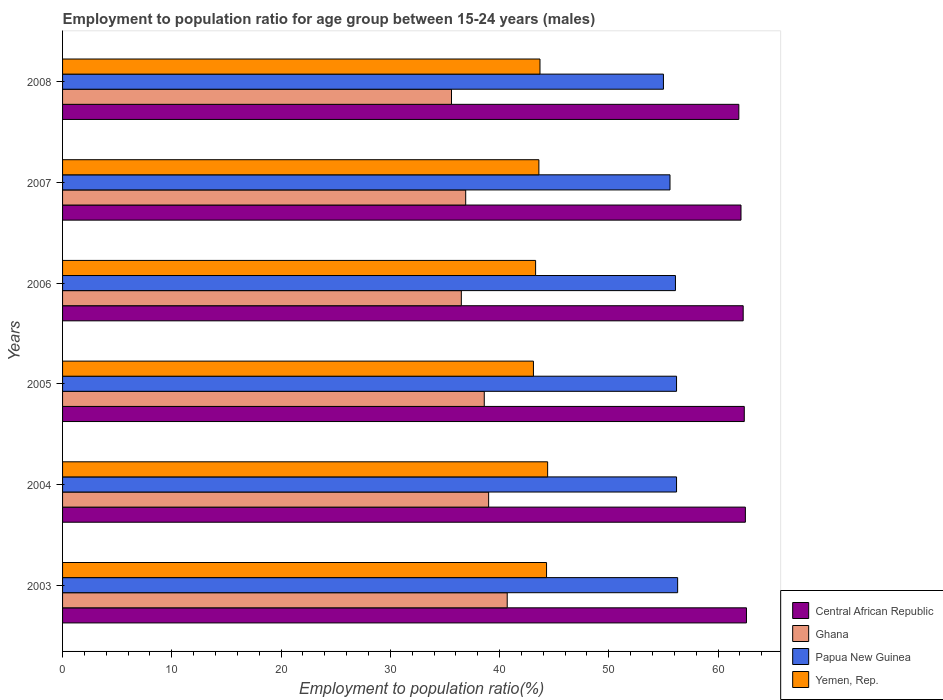How many different coloured bars are there?
Offer a terse response. 4. How many groups of bars are there?
Ensure brevity in your answer.  6. How many bars are there on the 4th tick from the bottom?
Provide a short and direct response. 4. What is the employment to population ratio in Central African Republic in 2006?
Give a very brief answer. 62.3. Across all years, what is the maximum employment to population ratio in Ghana?
Give a very brief answer. 40.7. Across all years, what is the minimum employment to population ratio in Ghana?
Offer a very short reply. 35.6. In which year was the employment to population ratio in Ghana minimum?
Your answer should be compact. 2008. What is the total employment to population ratio in Central African Republic in the graph?
Your answer should be compact. 373.8. What is the difference between the employment to population ratio in Central African Republic in 2004 and that in 2006?
Ensure brevity in your answer.  0.2. What is the difference between the employment to population ratio in Papua New Guinea in 2004 and the employment to population ratio in Yemen, Rep. in 2006?
Provide a short and direct response. 12.9. What is the average employment to population ratio in Papua New Guinea per year?
Offer a terse response. 55.9. In the year 2005, what is the difference between the employment to population ratio in Central African Republic and employment to population ratio in Ghana?
Your response must be concise. 23.8. What is the ratio of the employment to population ratio in Yemen, Rep. in 2005 to that in 2006?
Make the answer very short. 1. Is the employment to population ratio in Papua New Guinea in 2003 less than that in 2005?
Offer a terse response. No. Is the difference between the employment to population ratio in Central African Republic in 2004 and 2005 greater than the difference between the employment to population ratio in Ghana in 2004 and 2005?
Offer a terse response. No. What is the difference between the highest and the second highest employment to population ratio in Papua New Guinea?
Your answer should be very brief. 0.1. What is the difference between the highest and the lowest employment to population ratio in Papua New Guinea?
Ensure brevity in your answer.  1.3. Is it the case that in every year, the sum of the employment to population ratio in Ghana and employment to population ratio in Yemen, Rep. is greater than the sum of employment to population ratio in Papua New Guinea and employment to population ratio in Central African Republic?
Offer a terse response. Yes. What does the 2nd bar from the top in 2008 represents?
Offer a very short reply. Papua New Guinea. What does the 1st bar from the bottom in 2005 represents?
Keep it short and to the point. Central African Republic. Is it the case that in every year, the sum of the employment to population ratio in Yemen, Rep. and employment to population ratio in Papua New Guinea is greater than the employment to population ratio in Ghana?
Keep it short and to the point. Yes. How many bars are there?
Give a very brief answer. 24. Are all the bars in the graph horizontal?
Your answer should be very brief. Yes. How many years are there in the graph?
Keep it short and to the point. 6. What is the difference between two consecutive major ticks on the X-axis?
Offer a very short reply. 10. Are the values on the major ticks of X-axis written in scientific E-notation?
Your answer should be compact. No. Does the graph contain any zero values?
Ensure brevity in your answer.  No. How are the legend labels stacked?
Offer a terse response. Vertical. What is the title of the graph?
Ensure brevity in your answer.  Employment to population ratio for age group between 15-24 years (males). What is the label or title of the X-axis?
Your answer should be very brief. Employment to population ratio(%). What is the label or title of the Y-axis?
Provide a succinct answer. Years. What is the Employment to population ratio(%) in Central African Republic in 2003?
Provide a succinct answer. 62.6. What is the Employment to population ratio(%) of Ghana in 2003?
Offer a terse response. 40.7. What is the Employment to population ratio(%) in Papua New Guinea in 2003?
Provide a short and direct response. 56.3. What is the Employment to population ratio(%) of Yemen, Rep. in 2003?
Your answer should be compact. 44.3. What is the Employment to population ratio(%) in Central African Republic in 2004?
Ensure brevity in your answer.  62.5. What is the Employment to population ratio(%) of Papua New Guinea in 2004?
Your response must be concise. 56.2. What is the Employment to population ratio(%) in Yemen, Rep. in 2004?
Your answer should be very brief. 44.4. What is the Employment to population ratio(%) in Central African Republic in 2005?
Offer a terse response. 62.4. What is the Employment to population ratio(%) of Ghana in 2005?
Give a very brief answer. 38.6. What is the Employment to population ratio(%) in Papua New Guinea in 2005?
Provide a succinct answer. 56.2. What is the Employment to population ratio(%) in Yemen, Rep. in 2005?
Give a very brief answer. 43.1. What is the Employment to population ratio(%) of Central African Republic in 2006?
Offer a terse response. 62.3. What is the Employment to population ratio(%) of Ghana in 2006?
Your response must be concise. 36.5. What is the Employment to population ratio(%) of Papua New Guinea in 2006?
Provide a short and direct response. 56.1. What is the Employment to population ratio(%) of Yemen, Rep. in 2006?
Offer a terse response. 43.3. What is the Employment to population ratio(%) of Central African Republic in 2007?
Your answer should be very brief. 62.1. What is the Employment to population ratio(%) of Ghana in 2007?
Your answer should be very brief. 36.9. What is the Employment to population ratio(%) in Papua New Guinea in 2007?
Give a very brief answer. 55.6. What is the Employment to population ratio(%) in Yemen, Rep. in 2007?
Offer a very short reply. 43.6. What is the Employment to population ratio(%) of Central African Republic in 2008?
Keep it short and to the point. 61.9. What is the Employment to population ratio(%) of Ghana in 2008?
Your answer should be very brief. 35.6. What is the Employment to population ratio(%) of Yemen, Rep. in 2008?
Your answer should be compact. 43.7. Across all years, what is the maximum Employment to population ratio(%) in Central African Republic?
Offer a very short reply. 62.6. Across all years, what is the maximum Employment to population ratio(%) of Ghana?
Offer a very short reply. 40.7. Across all years, what is the maximum Employment to population ratio(%) in Papua New Guinea?
Your response must be concise. 56.3. Across all years, what is the maximum Employment to population ratio(%) of Yemen, Rep.?
Give a very brief answer. 44.4. Across all years, what is the minimum Employment to population ratio(%) in Central African Republic?
Make the answer very short. 61.9. Across all years, what is the minimum Employment to population ratio(%) in Ghana?
Offer a very short reply. 35.6. Across all years, what is the minimum Employment to population ratio(%) of Yemen, Rep.?
Offer a very short reply. 43.1. What is the total Employment to population ratio(%) in Central African Republic in the graph?
Provide a short and direct response. 373.8. What is the total Employment to population ratio(%) of Ghana in the graph?
Provide a succinct answer. 227.3. What is the total Employment to population ratio(%) of Papua New Guinea in the graph?
Keep it short and to the point. 335.4. What is the total Employment to population ratio(%) in Yemen, Rep. in the graph?
Your answer should be very brief. 262.4. What is the difference between the Employment to population ratio(%) of Central African Republic in 2003 and that in 2004?
Ensure brevity in your answer.  0.1. What is the difference between the Employment to population ratio(%) of Papua New Guinea in 2003 and that in 2004?
Offer a terse response. 0.1. What is the difference between the Employment to population ratio(%) in Yemen, Rep. in 2003 and that in 2004?
Make the answer very short. -0.1. What is the difference between the Employment to population ratio(%) of Central African Republic in 2003 and that in 2005?
Offer a terse response. 0.2. What is the difference between the Employment to population ratio(%) in Yemen, Rep. in 2003 and that in 2005?
Make the answer very short. 1.2. What is the difference between the Employment to population ratio(%) in Ghana in 2003 and that in 2006?
Make the answer very short. 4.2. What is the difference between the Employment to population ratio(%) in Papua New Guinea in 2003 and that in 2006?
Offer a terse response. 0.2. What is the difference between the Employment to population ratio(%) of Yemen, Rep. in 2003 and that in 2006?
Your answer should be compact. 1. What is the difference between the Employment to population ratio(%) of Central African Republic in 2003 and that in 2007?
Your response must be concise. 0.5. What is the difference between the Employment to population ratio(%) in Ghana in 2003 and that in 2007?
Offer a terse response. 3.8. What is the difference between the Employment to population ratio(%) in Central African Republic in 2003 and that in 2008?
Offer a very short reply. 0.7. What is the difference between the Employment to population ratio(%) in Ghana in 2003 and that in 2008?
Keep it short and to the point. 5.1. What is the difference between the Employment to population ratio(%) in Papua New Guinea in 2003 and that in 2008?
Offer a very short reply. 1.3. What is the difference between the Employment to population ratio(%) of Ghana in 2004 and that in 2005?
Your answer should be very brief. 0.4. What is the difference between the Employment to population ratio(%) in Yemen, Rep. in 2004 and that in 2005?
Provide a short and direct response. 1.3. What is the difference between the Employment to population ratio(%) of Ghana in 2004 and that in 2006?
Offer a terse response. 2.5. What is the difference between the Employment to population ratio(%) of Papua New Guinea in 2004 and that in 2006?
Your answer should be very brief. 0.1. What is the difference between the Employment to population ratio(%) in Central African Republic in 2004 and that in 2007?
Offer a very short reply. 0.4. What is the difference between the Employment to population ratio(%) in Yemen, Rep. in 2004 and that in 2008?
Ensure brevity in your answer.  0.7. What is the difference between the Employment to population ratio(%) of Central African Republic in 2005 and that in 2006?
Your answer should be compact. 0.1. What is the difference between the Employment to population ratio(%) in Ghana in 2005 and that in 2007?
Provide a succinct answer. 1.7. What is the difference between the Employment to population ratio(%) of Ghana in 2005 and that in 2008?
Offer a very short reply. 3. What is the difference between the Employment to population ratio(%) of Papua New Guinea in 2005 and that in 2008?
Make the answer very short. 1.2. What is the difference between the Employment to population ratio(%) in Yemen, Rep. in 2005 and that in 2008?
Make the answer very short. -0.6. What is the difference between the Employment to population ratio(%) in Papua New Guinea in 2006 and that in 2008?
Keep it short and to the point. 1.1. What is the difference between the Employment to population ratio(%) in Central African Republic in 2003 and the Employment to population ratio(%) in Ghana in 2004?
Provide a short and direct response. 23.6. What is the difference between the Employment to population ratio(%) in Central African Republic in 2003 and the Employment to population ratio(%) in Papua New Guinea in 2004?
Provide a succinct answer. 6.4. What is the difference between the Employment to population ratio(%) of Ghana in 2003 and the Employment to population ratio(%) of Papua New Guinea in 2004?
Keep it short and to the point. -15.5. What is the difference between the Employment to population ratio(%) in Papua New Guinea in 2003 and the Employment to population ratio(%) in Yemen, Rep. in 2004?
Keep it short and to the point. 11.9. What is the difference between the Employment to population ratio(%) in Central African Republic in 2003 and the Employment to population ratio(%) in Ghana in 2005?
Your answer should be compact. 24. What is the difference between the Employment to population ratio(%) of Central African Republic in 2003 and the Employment to population ratio(%) of Papua New Guinea in 2005?
Provide a short and direct response. 6.4. What is the difference between the Employment to population ratio(%) of Central African Republic in 2003 and the Employment to population ratio(%) of Yemen, Rep. in 2005?
Your response must be concise. 19.5. What is the difference between the Employment to population ratio(%) in Ghana in 2003 and the Employment to population ratio(%) in Papua New Guinea in 2005?
Your answer should be compact. -15.5. What is the difference between the Employment to population ratio(%) of Papua New Guinea in 2003 and the Employment to population ratio(%) of Yemen, Rep. in 2005?
Keep it short and to the point. 13.2. What is the difference between the Employment to population ratio(%) of Central African Republic in 2003 and the Employment to population ratio(%) of Ghana in 2006?
Ensure brevity in your answer.  26.1. What is the difference between the Employment to population ratio(%) in Central African Republic in 2003 and the Employment to population ratio(%) in Yemen, Rep. in 2006?
Keep it short and to the point. 19.3. What is the difference between the Employment to population ratio(%) of Ghana in 2003 and the Employment to population ratio(%) of Papua New Guinea in 2006?
Offer a terse response. -15.4. What is the difference between the Employment to population ratio(%) in Central African Republic in 2003 and the Employment to population ratio(%) in Ghana in 2007?
Keep it short and to the point. 25.7. What is the difference between the Employment to population ratio(%) of Central African Republic in 2003 and the Employment to population ratio(%) of Papua New Guinea in 2007?
Your answer should be compact. 7. What is the difference between the Employment to population ratio(%) in Ghana in 2003 and the Employment to population ratio(%) in Papua New Guinea in 2007?
Your answer should be compact. -14.9. What is the difference between the Employment to population ratio(%) in Ghana in 2003 and the Employment to population ratio(%) in Yemen, Rep. in 2007?
Provide a short and direct response. -2.9. What is the difference between the Employment to population ratio(%) of Papua New Guinea in 2003 and the Employment to population ratio(%) of Yemen, Rep. in 2007?
Ensure brevity in your answer.  12.7. What is the difference between the Employment to population ratio(%) in Central African Republic in 2003 and the Employment to population ratio(%) in Ghana in 2008?
Offer a very short reply. 27. What is the difference between the Employment to population ratio(%) of Central African Republic in 2003 and the Employment to population ratio(%) of Papua New Guinea in 2008?
Make the answer very short. 7.6. What is the difference between the Employment to population ratio(%) of Ghana in 2003 and the Employment to population ratio(%) of Papua New Guinea in 2008?
Offer a very short reply. -14.3. What is the difference between the Employment to population ratio(%) of Papua New Guinea in 2003 and the Employment to population ratio(%) of Yemen, Rep. in 2008?
Provide a succinct answer. 12.6. What is the difference between the Employment to population ratio(%) in Central African Republic in 2004 and the Employment to population ratio(%) in Ghana in 2005?
Provide a succinct answer. 23.9. What is the difference between the Employment to population ratio(%) in Central African Republic in 2004 and the Employment to population ratio(%) in Yemen, Rep. in 2005?
Give a very brief answer. 19.4. What is the difference between the Employment to population ratio(%) of Ghana in 2004 and the Employment to population ratio(%) of Papua New Guinea in 2005?
Ensure brevity in your answer.  -17.2. What is the difference between the Employment to population ratio(%) of Papua New Guinea in 2004 and the Employment to population ratio(%) of Yemen, Rep. in 2005?
Offer a terse response. 13.1. What is the difference between the Employment to population ratio(%) in Central African Republic in 2004 and the Employment to population ratio(%) in Ghana in 2006?
Offer a terse response. 26. What is the difference between the Employment to population ratio(%) in Central African Republic in 2004 and the Employment to population ratio(%) in Papua New Guinea in 2006?
Ensure brevity in your answer.  6.4. What is the difference between the Employment to population ratio(%) of Ghana in 2004 and the Employment to population ratio(%) of Papua New Guinea in 2006?
Make the answer very short. -17.1. What is the difference between the Employment to population ratio(%) in Ghana in 2004 and the Employment to population ratio(%) in Yemen, Rep. in 2006?
Your answer should be very brief. -4.3. What is the difference between the Employment to population ratio(%) of Central African Republic in 2004 and the Employment to population ratio(%) of Ghana in 2007?
Offer a terse response. 25.6. What is the difference between the Employment to population ratio(%) in Central African Republic in 2004 and the Employment to population ratio(%) in Papua New Guinea in 2007?
Give a very brief answer. 6.9. What is the difference between the Employment to population ratio(%) in Ghana in 2004 and the Employment to population ratio(%) in Papua New Guinea in 2007?
Offer a very short reply. -16.6. What is the difference between the Employment to population ratio(%) of Ghana in 2004 and the Employment to population ratio(%) of Yemen, Rep. in 2007?
Give a very brief answer. -4.6. What is the difference between the Employment to population ratio(%) of Central African Republic in 2004 and the Employment to population ratio(%) of Ghana in 2008?
Offer a very short reply. 26.9. What is the difference between the Employment to population ratio(%) in Central African Republic in 2004 and the Employment to population ratio(%) in Papua New Guinea in 2008?
Give a very brief answer. 7.5. What is the difference between the Employment to population ratio(%) in Ghana in 2004 and the Employment to population ratio(%) in Papua New Guinea in 2008?
Ensure brevity in your answer.  -16. What is the difference between the Employment to population ratio(%) in Ghana in 2004 and the Employment to population ratio(%) in Yemen, Rep. in 2008?
Offer a very short reply. -4.7. What is the difference between the Employment to population ratio(%) of Papua New Guinea in 2004 and the Employment to population ratio(%) of Yemen, Rep. in 2008?
Offer a very short reply. 12.5. What is the difference between the Employment to population ratio(%) of Central African Republic in 2005 and the Employment to population ratio(%) of Ghana in 2006?
Make the answer very short. 25.9. What is the difference between the Employment to population ratio(%) in Central African Republic in 2005 and the Employment to population ratio(%) in Papua New Guinea in 2006?
Keep it short and to the point. 6.3. What is the difference between the Employment to population ratio(%) in Ghana in 2005 and the Employment to population ratio(%) in Papua New Guinea in 2006?
Your response must be concise. -17.5. What is the difference between the Employment to population ratio(%) in Papua New Guinea in 2005 and the Employment to population ratio(%) in Yemen, Rep. in 2006?
Offer a very short reply. 12.9. What is the difference between the Employment to population ratio(%) of Central African Republic in 2005 and the Employment to population ratio(%) of Papua New Guinea in 2007?
Your answer should be very brief. 6.8. What is the difference between the Employment to population ratio(%) in Ghana in 2005 and the Employment to population ratio(%) in Yemen, Rep. in 2007?
Your answer should be compact. -5. What is the difference between the Employment to population ratio(%) of Papua New Guinea in 2005 and the Employment to population ratio(%) of Yemen, Rep. in 2007?
Offer a terse response. 12.6. What is the difference between the Employment to population ratio(%) of Central African Republic in 2005 and the Employment to population ratio(%) of Ghana in 2008?
Offer a terse response. 26.8. What is the difference between the Employment to population ratio(%) of Central African Republic in 2005 and the Employment to population ratio(%) of Yemen, Rep. in 2008?
Make the answer very short. 18.7. What is the difference between the Employment to population ratio(%) in Ghana in 2005 and the Employment to population ratio(%) in Papua New Guinea in 2008?
Your answer should be compact. -16.4. What is the difference between the Employment to population ratio(%) in Ghana in 2005 and the Employment to population ratio(%) in Yemen, Rep. in 2008?
Your response must be concise. -5.1. What is the difference between the Employment to population ratio(%) in Papua New Guinea in 2005 and the Employment to population ratio(%) in Yemen, Rep. in 2008?
Give a very brief answer. 12.5. What is the difference between the Employment to population ratio(%) in Central African Republic in 2006 and the Employment to population ratio(%) in Ghana in 2007?
Make the answer very short. 25.4. What is the difference between the Employment to population ratio(%) in Central African Republic in 2006 and the Employment to population ratio(%) in Yemen, Rep. in 2007?
Your response must be concise. 18.7. What is the difference between the Employment to population ratio(%) of Ghana in 2006 and the Employment to population ratio(%) of Papua New Guinea in 2007?
Give a very brief answer. -19.1. What is the difference between the Employment to population ratio(%) in Papua New Guinea in 2006 and the Employment to population ratio(%) in Yemen, Rep. in 2007?
Give a very brief answer. 12.5. What is the difference between the Employment to population ratio(%) of Central African Republic in 2006 and the Employment to population ratio(%) of Ghana in 2008?
Ensure brevity in your answer.  26.7. What is the difference between the Employment to population ratio(%) in Central African Republic in 2006 and the Employment to population ratio(%) in Papua New Guinea in 2008?
Give a very brief answer. 7.3. What is the difference between the Employment to population ratio(%) in Central African Republic in 2006 and the Employment to population ratio(%) in Yemen, Rep. in 2008?
Your answer should be compact. 18.6. What is the difference between the Employment to population ratio(%) in Ghana in 2006 and the Employment to population ratio(%) in Papua New Guinea in 2008?
Offer a terse response. -18.5. What is the difference between the Employment to population ratio(%) in Ghana in 2006 and the Employment to population ratio(%) in Yemen, Rep. in 2008?
Provide a succinct answer. -7.2. What is the difference between the Employment to population ratio(%) in Papua New Guinea in 2006 and the Employment to population ratio(%) in Yemen, Rep. in 2008?
Ensure brevity in your answer.  12.4. What is the difference between the Employment to population ratio(%) in Central African Republic in 2007 and the Employment to population ratio(%) in Ghana in 2008?
Your response must be concise. 26.5. What is the difference between the Employment to population ratio(%) of Ghana in 2007 and the Employment to population ratio(%) of Papua New Guinea in 2008?
Give a very brief answer. -18.1. What is the average Employment to population ratio(%) in Central African Republic per year?
Make the answer very short. 62.3. What is the average Employment to population ratio(%) in Ghana per year?
Keep it short and to the point. 37.88. What is the average Employment to population ratio(%) in Papua New Guinea per year?
Keep it short and to the point. 55.9. What is the average Employment to population ratio(%) of Yemen, Rep. per year?
Make the answer very short. 43.73. In the year 2003, what is the difference between the Employment to population ratio(%) in Central African Republic and Employment to population ratio(%) in Ghana?
Offer a very short reply. 21.9. In the year 2003, what is the difference between the Employment to population ratio(%) of Central African Republic and Employment to population ratio(%) of Yemen, Rep.?
Your answer should be very brief. 18.3. In the year 2003, what is the difference between the Employment to population ratio(%) of Ghana and Employment to population ratio(%) of Papua New Guinea?
Give a very brief answer. -15.6. In the year 2003, what is the difference between the Employment to population ratio(%) of Ghana and Employment to population ratio(%) of Yemen, Rep.?
Provide a succinct answer. -3.6. In the year 2003, what is the difference between the Employment to population ratio(%) of Papua New Guinea and Employment to population ratio(%) of Yemen, Rep.?
Ensure brevity in your answer.  12. In the year 2004, what is the difference between the Employment to population ratio(%) of Central African Republic and Employment to population ratio(%) of Ghana?
Your response must be concise. 23.5. In the year 2004, what is the difference between the Employment to population ratio(%) in Ghana and Employment to population ratio(%) in Papua New Guinea?
Make the answer very short. -17.2. In the year 2005, what is the difference between the Employment to population ratio(%) of Central African Republic and Employment to population ratio(%) of Ghana?
Give a very brief answer. 23.8. In the year 2005, what is the difference between the Employment to population ratio(%) in Central African Republic and Employment to population ratio(%) in Papua New Guinea?
Ensure brevity in your answer.  6.2. In the year 2005, what is the difference between the Employment to population ratio(%) in Central African Republic and Employment to population ratio(%) in Yemen, Rep.?
Your response must be concise. 19.3. In the year 2005, what is the difference between the Employment to population ratio(%) of Ghana and Employment to population ratio(%) of Papua New Guinea?
Ensure brevity in your answer.  -17.6. In the year 2005, what is the difference between the Employment to population ratio(%) of Papua New Guinea and Employment to population ratio(%) of Yemen, Rep.?
Your answer should be very brief. 13.1. In the year 2006, what is the difference between the Employment to population ratio(%) of Central African Republic and Employment to population ratio(%) of Ghana?
Your response must be concise. 25.8. In the year 2006, what is the difference between the Employment to population ratio(%) in Central African Republic and Employment to population ratio(%) in Papua New Guinea?
Your answer should be compact. 6.2. In the year 2006, what is the difference between the Employment to population ratio(%) of Central African Republic and Employment to population ratio(%) of Yemen, Rep.?
Your answer should be compact. 19. In the year 2006, what is the difference between the Employment to population ratio(%) of Ghana and Employment to population ratio(%) of Papua New Guinea?
Provide a succinct answer. -19.6. In the year 2006, what is the difference between the Employment to population ratio(%) of Ghana and Employment to population ratio(%) of Yemen, Rep.?
Offer a terse response. -6.8. In the year 2007, what is the difference between the Employment to population ratio(%) of Central African Republic and Employment to population ratio(%) of Ghana?
Provide a short and direct response. 25.2. In the year 2007, what is the difference between the Employment to population ratio(%) in Central African Republic and Employment to population ratio(%) in Yemen, Rep.?
Keep it short and to the point. 18.5. In the year 2007, what is the difference between the Employment to population ratio(%) of Ghana and Employment to population ratio(%) of Papua New Guinea?
Ensure brevity in your answer.  -18.7. In the year 2008, what is the difference between the Employment to population ratio(%) in Central African Republic and Employment to population ratio(%) in Ghana?
Ensure brevity in your answer.  26.3. In the year 2008, what is the difference between the Employment to population ratio(%) of Central African Republic and Employment to population ratio(%) of Yemen, Rep.?
Give a very brief answer. 18.2. In the year 2008, what is the difference between the Employment to population ratio(%) of Ghana and Employment to population ratio(%) of Papua New Guinea?
Make the answer very short. -19.4. In the year 2008, what is the difference between the Employment to population ratio(%) in Ghana and Employment to population ratio(%) in Yemen, Rep.?
Make the answer very short. -8.1. What is the ratio of the Employment to population ratio(%) in Central African Republic in 2003 to that in 2004?
Your answer should be compact. 1. What is the ratio of the Employment to population ratio(%) in Ghana in 2003 to that in 2004?
Make the answer very short. 1.04. What is the ratio of the Employment to population ratio(%) of Central African Republic in 2003 to that in 2005?
Give a very brief answer. 1. What is the ratio of the Employment to population ratio(%) of Ghana in 2003 to that in 2005?
Keep it short and to the point. 1.05. What is the ratio of the Employment to population ratio(%) in Papua New Guinea in 2003 to that in 2005?
Offer a very short reply. 1. What is the ratio of the Employment to population ratio(%) of Yemen, Rep. in 2003 to that in 2005?
Keep it short and to the point. 1.03. What is the ratio of the Employment to population ratio(%) of Ghana in 2003 to that in 2006?
Provide a short and direct response. 1.12. What is the ratio of the Employment to population ratio(%) of Yemen, Rep. in 2003 to that in 2006?
Make the answer very short. 1.02. What is the ratio of the Employment to population ratio(%) of Ghana in 2003 to that in 2007?
Make the answer very short. 1.1. What is the ratio of the Employment to population ratio(%) in Papua New Guinea in 2003 to that in 2007?
Give a very brief answer. 1.01. What is the ratio of the Employment to population ratio(%) in Yemen, Rep. in 2003 to that in 2007?
Your response must be concise. 1.02. What is the ratio of the Employment to population ratio(%) in Central African Republic in 2003 to that in 2008?
Make the answer very short. 1.01. What is the ratio of the Employment to population ratio(%) in Ghana in 2003 to that in 2008?
Make the answer very short. 1.14. What is the ratio of the Employment to population ratio(%) in Papua New Guinea in 2003 to that in 2008?
Give a very brief answer. 1.02. What is the ratio of the Employment to population ratio(%) in Yemen, Rep. in 2003 to that in 2008?
Your answer should be compact. 1.01. What is the ratio of the Employment to population ratio(%) of Central African Republic in 2004 to that in 2005?
Provide a succinct answer. 1. What is the ratio of the Employment to population ratio(%) in Ghana in 2004 to that in 2005?
Provide a short and direct response. 1.01. What is the ratio of the Employment to population ratio(%) of Yemen, Rep. in 2004 to that in 2005?
Provide a short and direct response. 1.03. What is the ratio of the Employment to population ratio(%) in Ghana in 2004 to that in 2006?
Give a very brief answer. 1.07. What is the ratio of the Employment to population ratio(%) in Yemen, Rep. in 2004 to that in 2006?
Your answer should be very brief. 1.03. What is the ratio of the Employment to population ratio(%) in Central African Republic in 2004 to that in 2007?
Your answer should be compact. 1.01. What is the ratio of the Employment to population ratio(%) of Ghana in 2004 to that in 2007?
Ensure brevity in your answer.  1.06. What is the ratio of the Employment to population ratio(%) in Papua New Guinea in 2004 to that in 2007?
Give a very brief answer. 1.01. What is the ratio of the Employment to population ratio(%) in Yemen, Rep. in 2004 to that in 2007?
Your answer should be compact. 1.02. What is the ratio of the Employment to population ratio(%) in Central African Republic in 2004 to that in 2008?
Make the answer very short. 1.01. What is the ratio of the Employment to population ratio(%) of Ghana in 2004 to that in 2008?
Keep it short and to the point. 1.1. What is the ratio of the Employment to population ratio(%) of Papua New Guinea in 2004 to that in 2008?
Your answer should be compact. 1.02. What is the ratio of the Employment to population ratio(%) of Central African Republic in 2005 to that in 2006?
Your response must be concise. 1. What is the ratio of the Employment to population ratio(%) of Ghana in 2005 to that in 2006?
Give a very brief answer. 1.06. What is the ratio of the Employment to population ratio(%) of Papua New Guinea in 2005 to that in 2006?
Make the answer very short. 1. What is the ratio of the Employment to population ratio(%) in Yemen, Rep. in 2005 to that in 2006?
Give a very brief answer. 1. What is the ratio of the Employment to population ratio(%) of Central African Republic in 2005 to that in 2007?
Provide a succinct answer. 1. What is the ratio of the Employment to population ratio(%) of Ghana in 2005 to that in 2007?
Offer a terse response. 1.05. What is the ratio of the Employment to population ratio(%) of Papua New Guinea in 2005 to that in 2007?
Offer a terse response. 1.01. What is the ratio of the Employment to population ratio(%) in Ghana in 2005 to that in 2008?
Provide a short and direct response. 1.08. What is the ratio of the Employment to population ratio(%) of Papua New Guinea in 2005 to that in 2008?
Provide a short and direct response. 1.02. What is the ratio of the Employment to population ratio(%) of Yemen, Rep. in 2005 to that in 2008?
Your answer should be very brief. 0.99. What is the ratio of the Employment to population ratio(%) in Central African Republic in 2006 to that in 2007?
Make the answer very short. 1. What is the ratio of the Employment to population ratio(%) of Papua New Guinea in 2006 to that in 2007?
Offer a terse response. 1.01. What is the ratio of the Employment to population ratio(%) of Ghana in 2006 to that in 2008?
Your answer should be very brief. 1.03. What is the ratio of the Employment to population ratio(%) of Papua New Guinea in 2006 to that in 2008?
Your answer should be compact. 1.02. What is the ratio of the Employment to population ratio(%) in Yemen, Rep. in 2006 to that in 2008?
Your response must be concise. 0.99. What is the ratio of the Employment to population ratio(%) in Ghana in 2007 to that in 2008?
Ensure brevity in your answer.  1.04. What is the ratio of the Employment to population ratio(%) of Papua New Guinea in 2007 to that in 2008?
Provide a short and direct response. 1.01. What is the ratio of the Employment to population ratio(%) of Yemen, Rep. in 2007 to that in 2008?
Ensure brevity in your answer.  1. What is the difference between the highest and the second highest Employment to population ratio(%) in Ghana?
Your answer should be compact. 1.7. What is the difference between the highest and the second highest Employment to population ratio(%) in Yemen, Rep.?
Your answer should be very brief. 0.1. What is the difference between the highest and the lowest Employment to population ratio(%) of Central African Republic?
Provide a succinct answer. 0.7. 